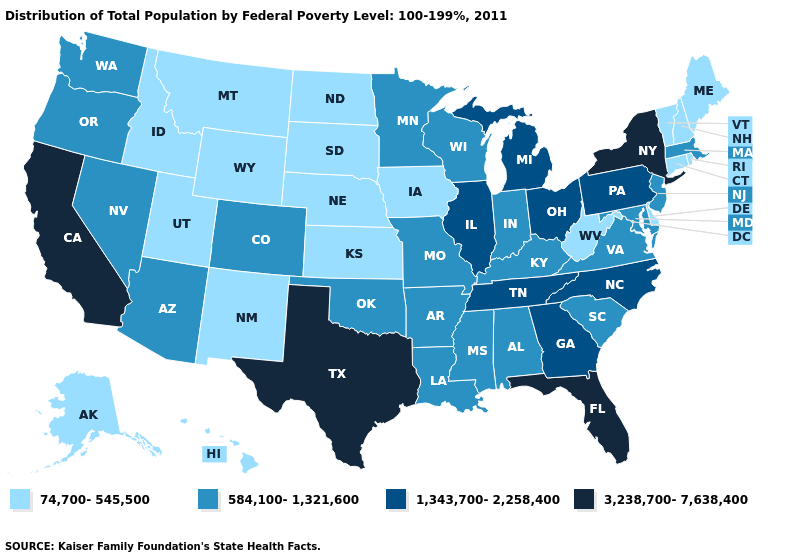Does the first symbol in the legend represent the smallest category?
Quick response, please. Yes. Does Idaho have the highest value in the West?
Give a very brief answer. No. Name the states that have a value in the range 3,238,700-7,638,400?
Keep it brief. California, Florida, New York, Texas. What is the value of West Virginia?
Write a very short answer. 74,700-545,500. What is the highest value in the MidWest ?
Keep it brief. 1,343,700-2,258,400. What is the value of Colorado?
Give a very brief answer. 584,100-1,321,600. Which states have the lowest value in the USA?
Quick response, please. Alaska, Connecticut, Delaware, Hawaii, Idaho, Iowa, Kansas, Maine, Montana, Nebraska, New Hampshire, New Mexico, North Dakota, Rhode Island, South Dakota, Utah, Vermont, West Virginia, Wyoming. Which states have the lowest value in the USA?
Quick response, please. Alaska, Connecticut, Delaware, Hawaii, Idaho, Iowa, Kansas, Maine, Montana, Nebraska, New Hampshire, New Mexico, North Dakota, Rhode Island, South Dakota, Utah, Vermont, West Virginia, Wyoming. Which states hav the highest value in the West?
Keep it brief. California. Which states have the lowest value in the USA?
Keep it brief. Alaska, Connecticut, Delaware, Hawaii, Idaho, Iowa, Kansas, Maine, Montana, Nebraska, New Hampshire, New Mexico, North Dakota, Rhode Island, South Dakota, Utah, Vermont, West Virginia, Wyoming. Among the states that border Mississippi , does Arkansas have the lowest value?
Quick response, please. Yes. What is the highest value in states that border Indiana?
Be succinct. 1,343,700-2,258,400. Name the states that have a value in the range 1,343,700-2,258,400?
Quick response, please. Georgia, Illinois, Michigan, North Carolina, Ohio, Pennsylvania, Tennessee. What is the value of Minnesota?
Concise answer only. 584,100-1,321,600. Which states have the lowest value in the USA?
Quick response, please. Alaska, Connecticut, Delaware, Hawaii, Idaho, Iowa, Kansas, Maine, Montana, Nebraska, New Hampshire, New Mexico, North Dakota, Rhode Island, South Dakota, Utah, Vermont, West Virginia, Wyoming. 